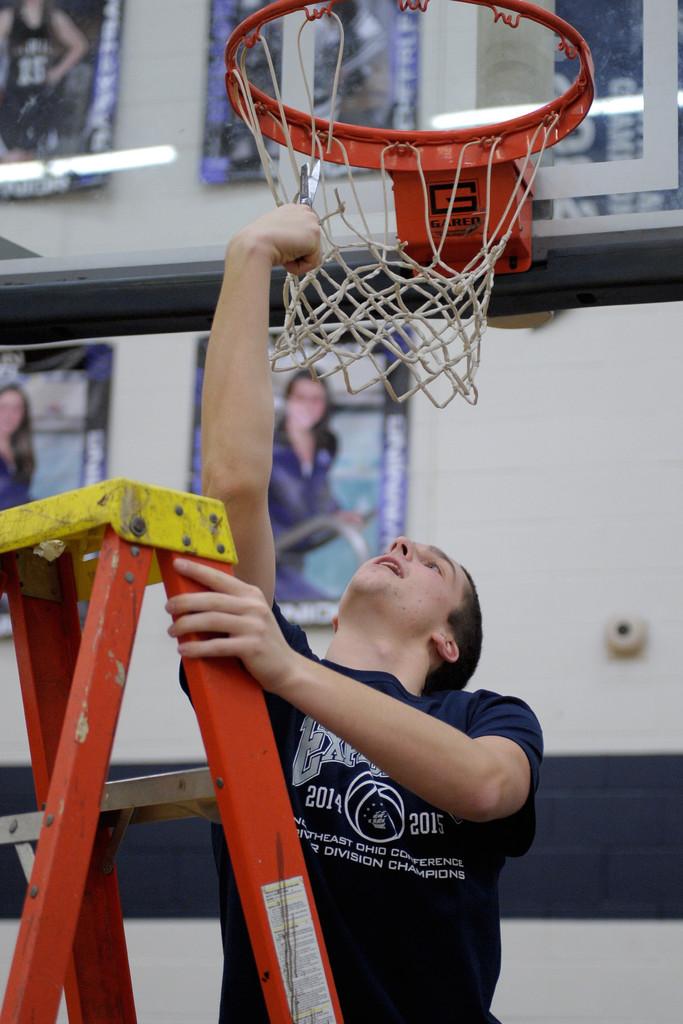What year is shown on the left, on the person's shirt?
Offer a terse response. 2014. 